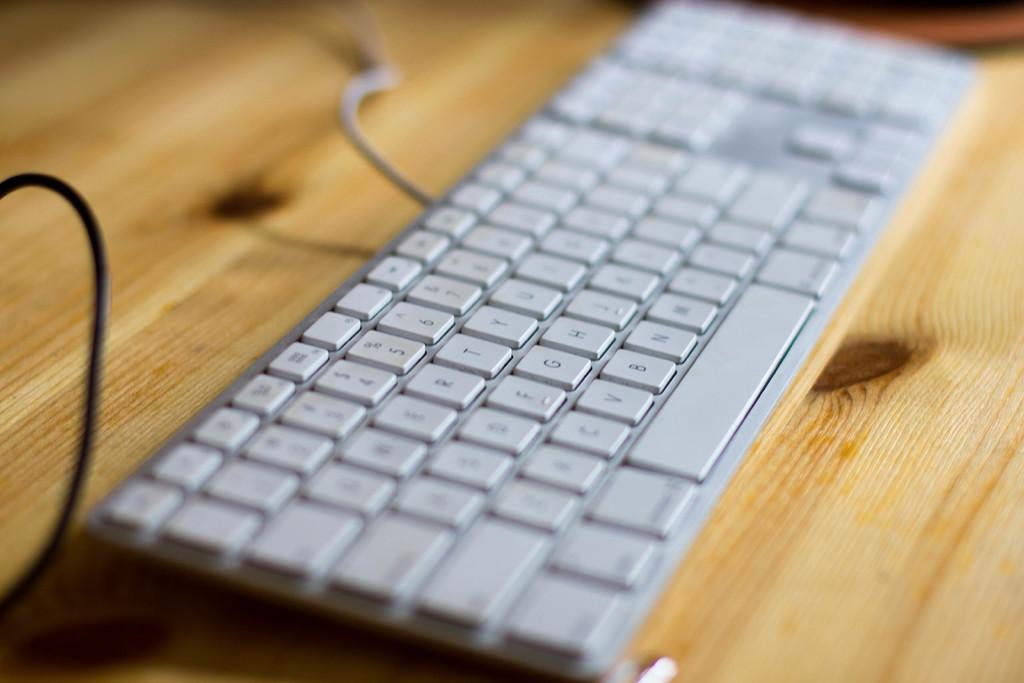What key is above the"g" key?
Provide a succinct answer. T. What key it to the right of the e key?
Offer a very short reply. R. 